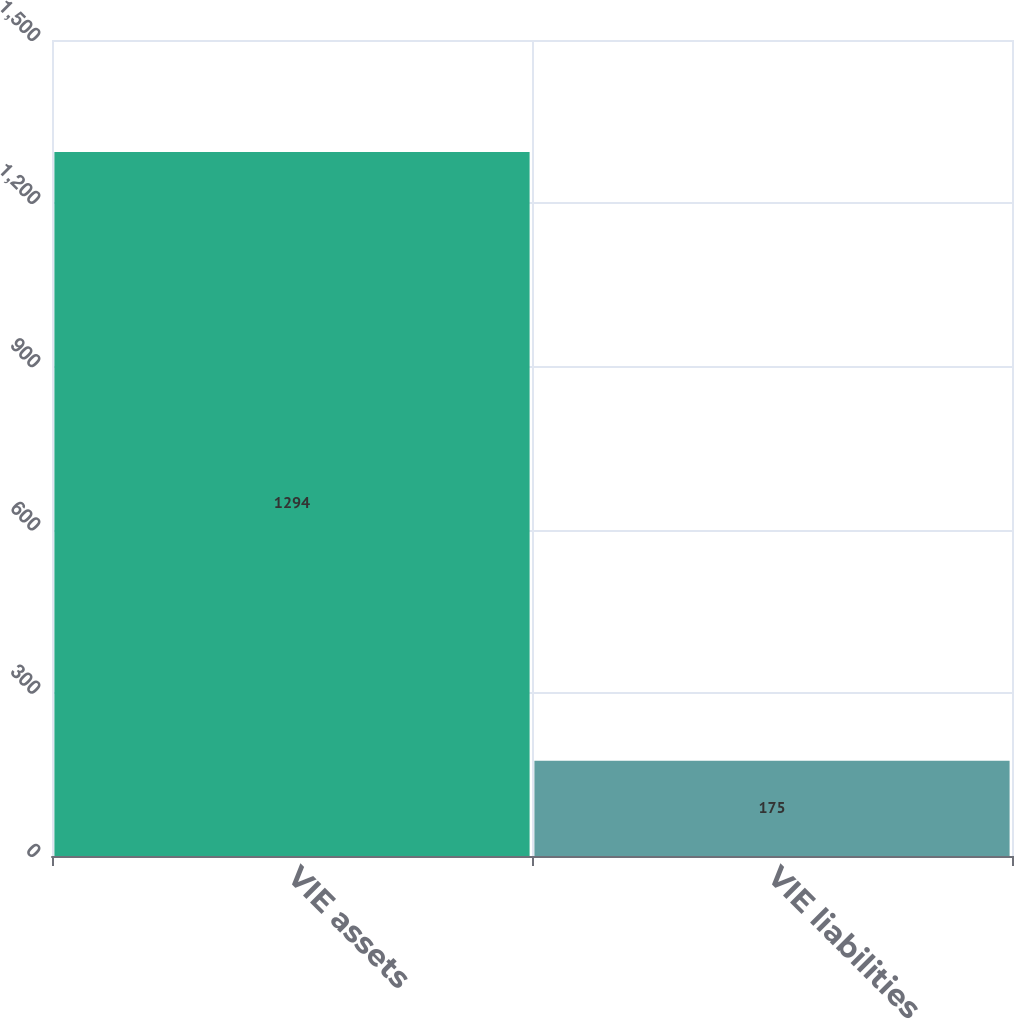Convert chart to OTSL. <chart><loc_0><loc_0><loc_500><loc_500><bar_chart><fcel>VIE assets<fcel>VIE liabilities<nl><fcel>1294<fcel>175<nl></chart> 